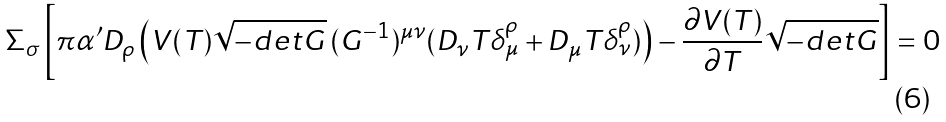Convert formula to latex. <formula><loc_0><loc_0><loc_500><loc_500>\Sigma _ { \sigma } \left [ \pi \alpha ^ { \prime } D _ { \rho } \left ( V ( T ) \sqrt { - d e t G } \, ( G ^ { - 1 } ) ^ { \mu \nu } ( D _ { \nu } T \delta _ { \mu } ^ { \rho } + D _ { \mu } T \delta _ { \nu } ^ { \rho } ) \right ) - \frac { \partial V ( T ) } { \partial T } \sqrt { - d e t G } \right ] = 0</formula> 